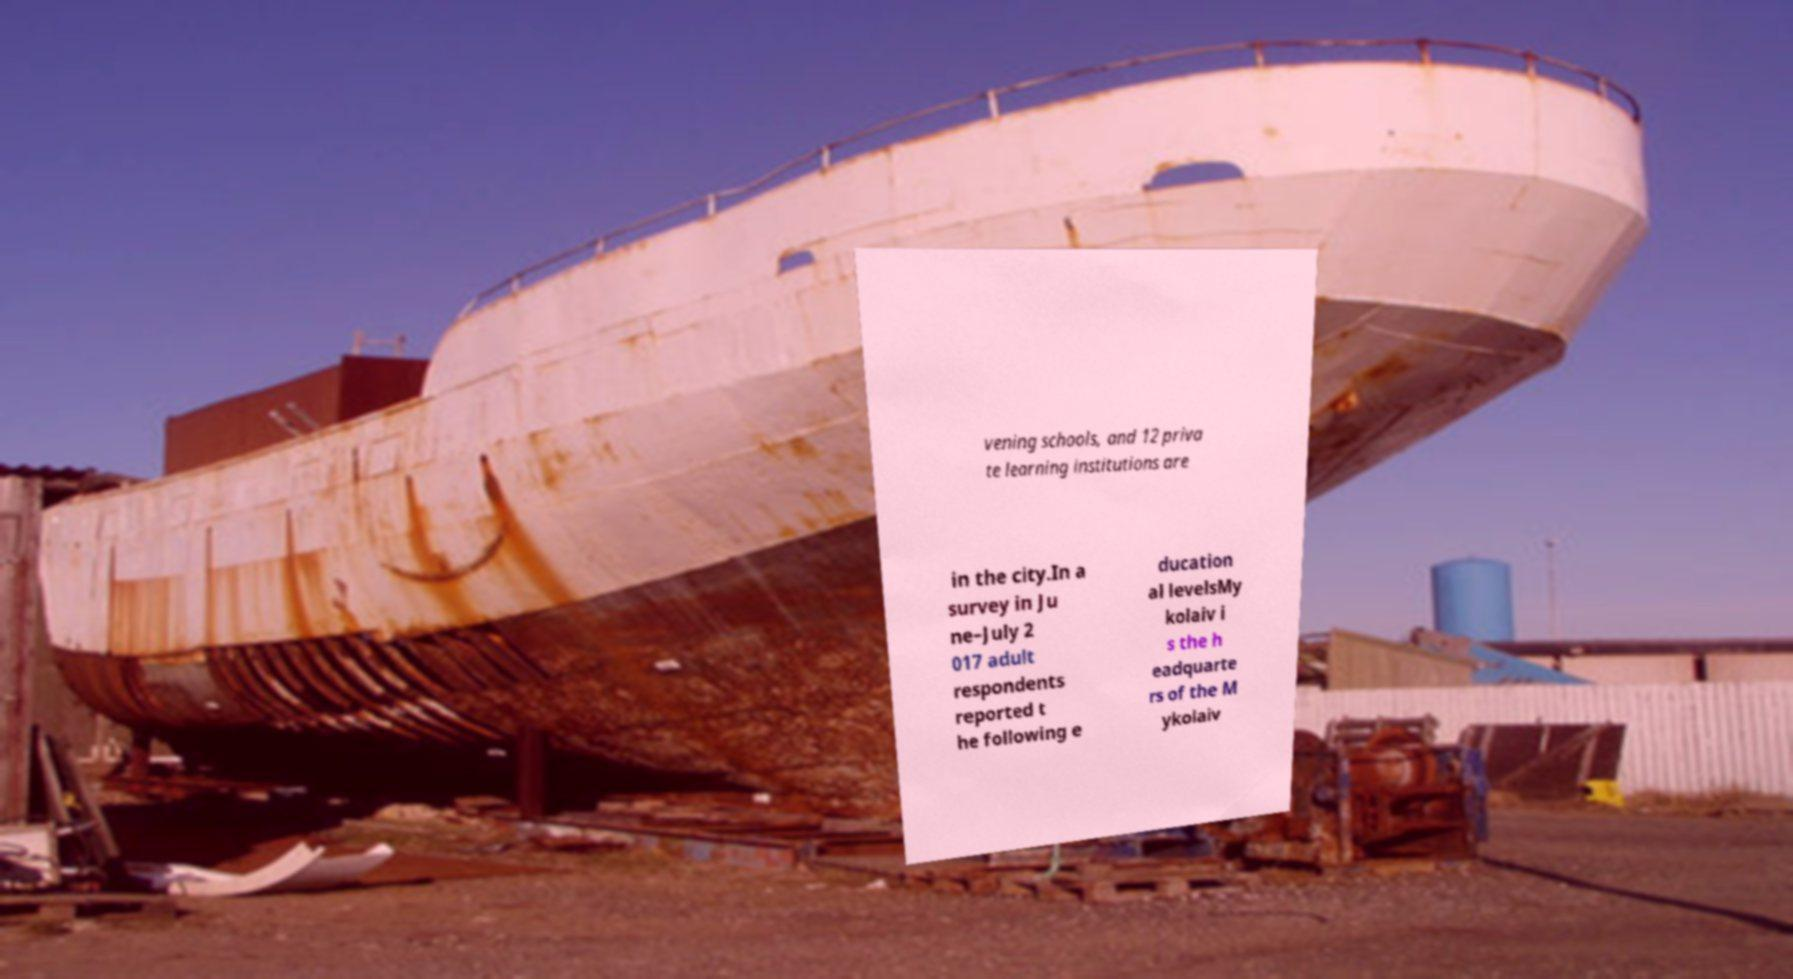What messages or text are displayed in this image? I need them in a readable, typed format. vening schools, and 12 priva te learning institutions are in the city.In a survey in Ju ne–July 2 017 adult respondents reported t he following e ducation al levelsMy kolaiv i s the h eadquarte rs of the M ykolaiv 